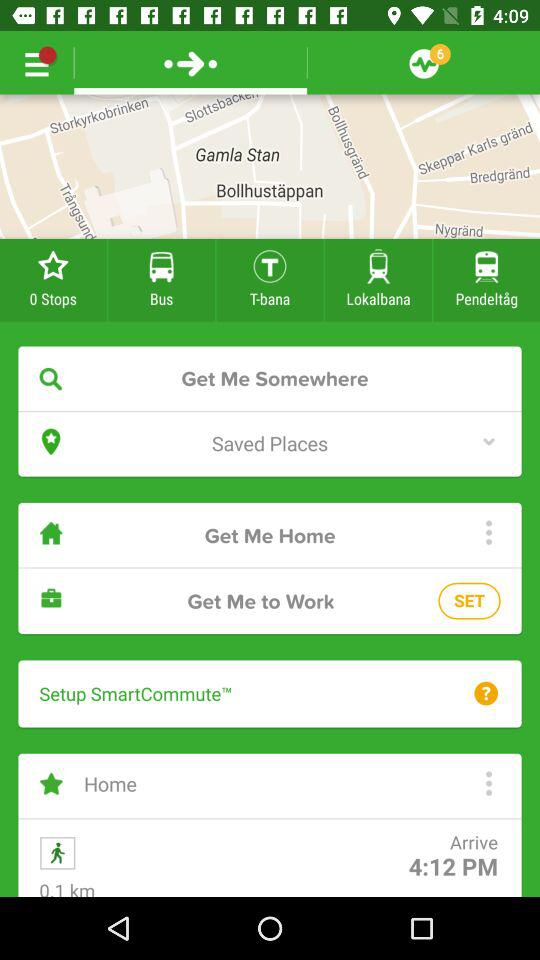What are the saved places?
When the provided information is insufficient, respond with <no answer>. <no answer> 